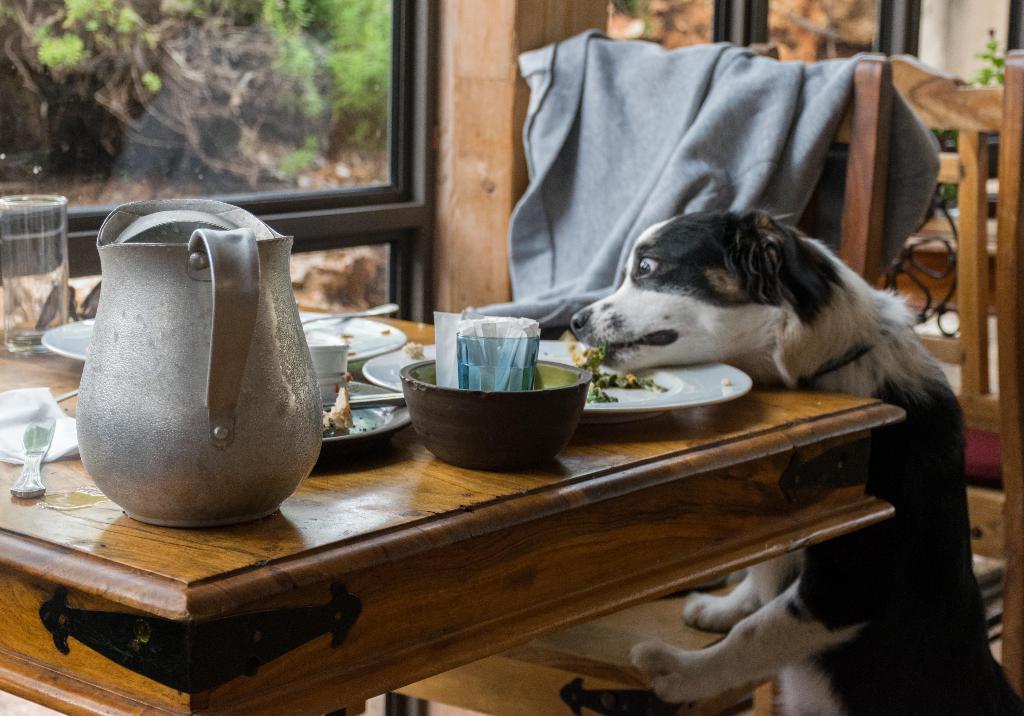Describe this image in one or two sentences. The picture consist of the Image of a dog eating some food from the plate, there is a table in front of the dog and on the table there are some tissues ,leftover food ,jar ,knives. Beside the table there is a chair and there is a jacket on the chair in the background there is a window outside the window are some trees. 